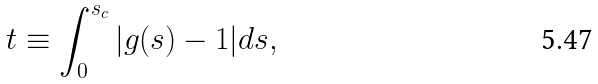<formula> <loc_0><loc_0><loc_500><loc_500>t \equiv \int _ { 0 } ^ { s _ { c } } | g ( s ) - 1 | d s ,</formula> 